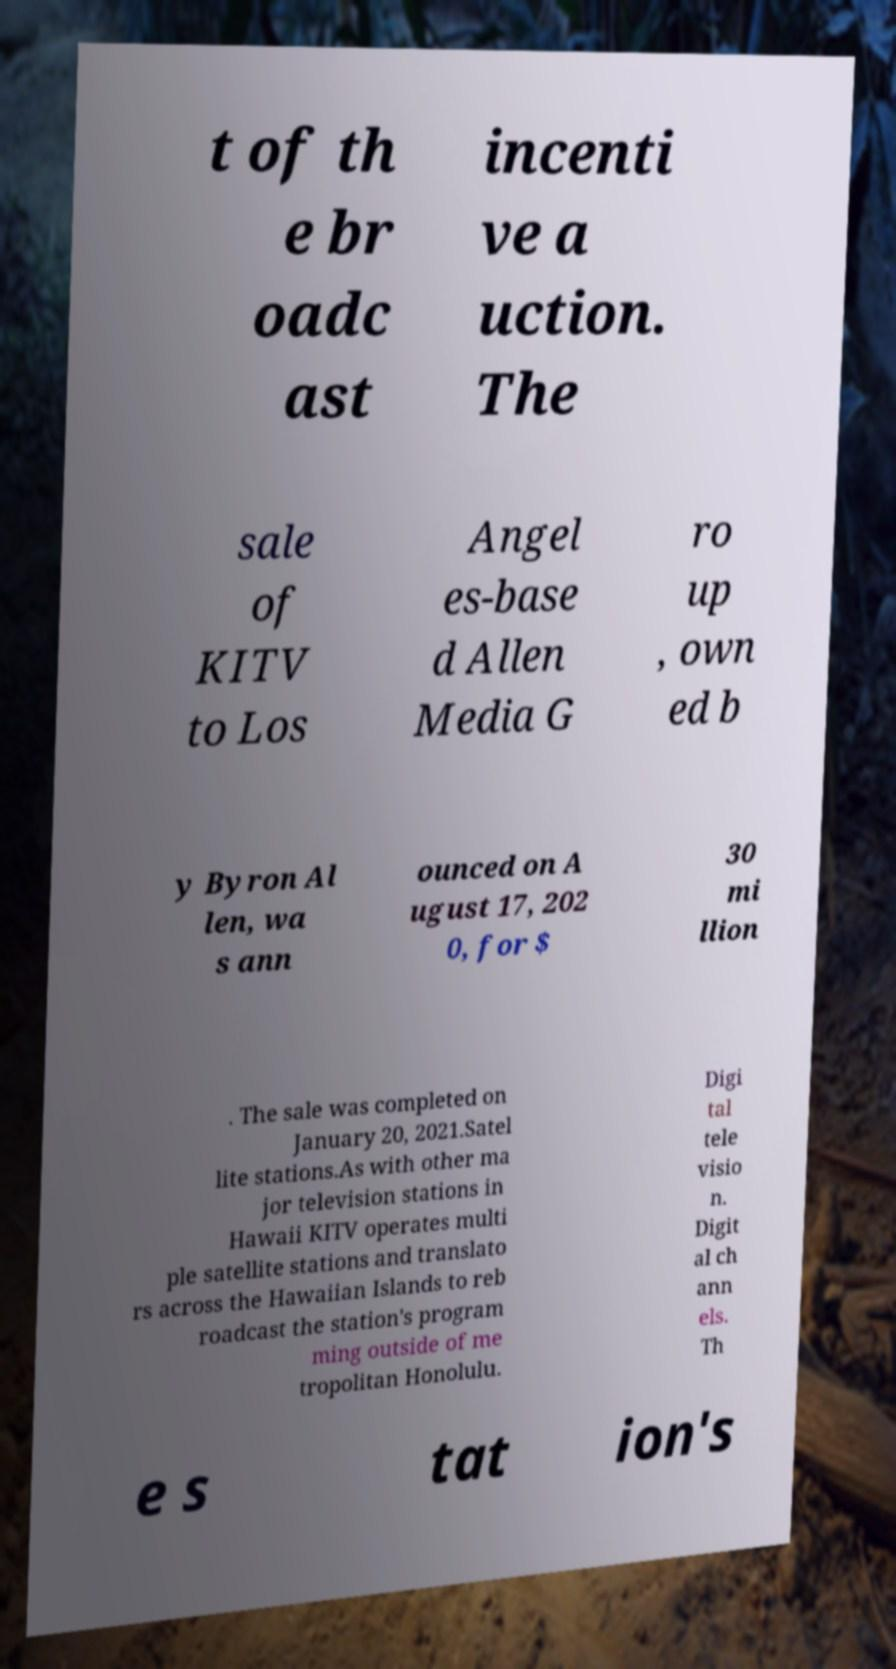Please identify and transcribe the text found in this image. t of th e br oadc ast incenti ve a uction. The sale of KITV to Los Angel es-base d Allen Media G ro up , own ed b y Byron Al len, wa s ann ounced on A ugust 17, 202 0, for $ 30 mi llion . The sale was completed on January 20, 2021.Satel lite stations.As with other ma jor television stations in Hawaii KITV operates multi ple satellite stations and translato rs across the Hawaiian Islands to reb roadcast the station's program ming outside of me tropolitan Honolulu. Digi tal tele visio n. Digit al ch ann els. Th e s tat ion's 